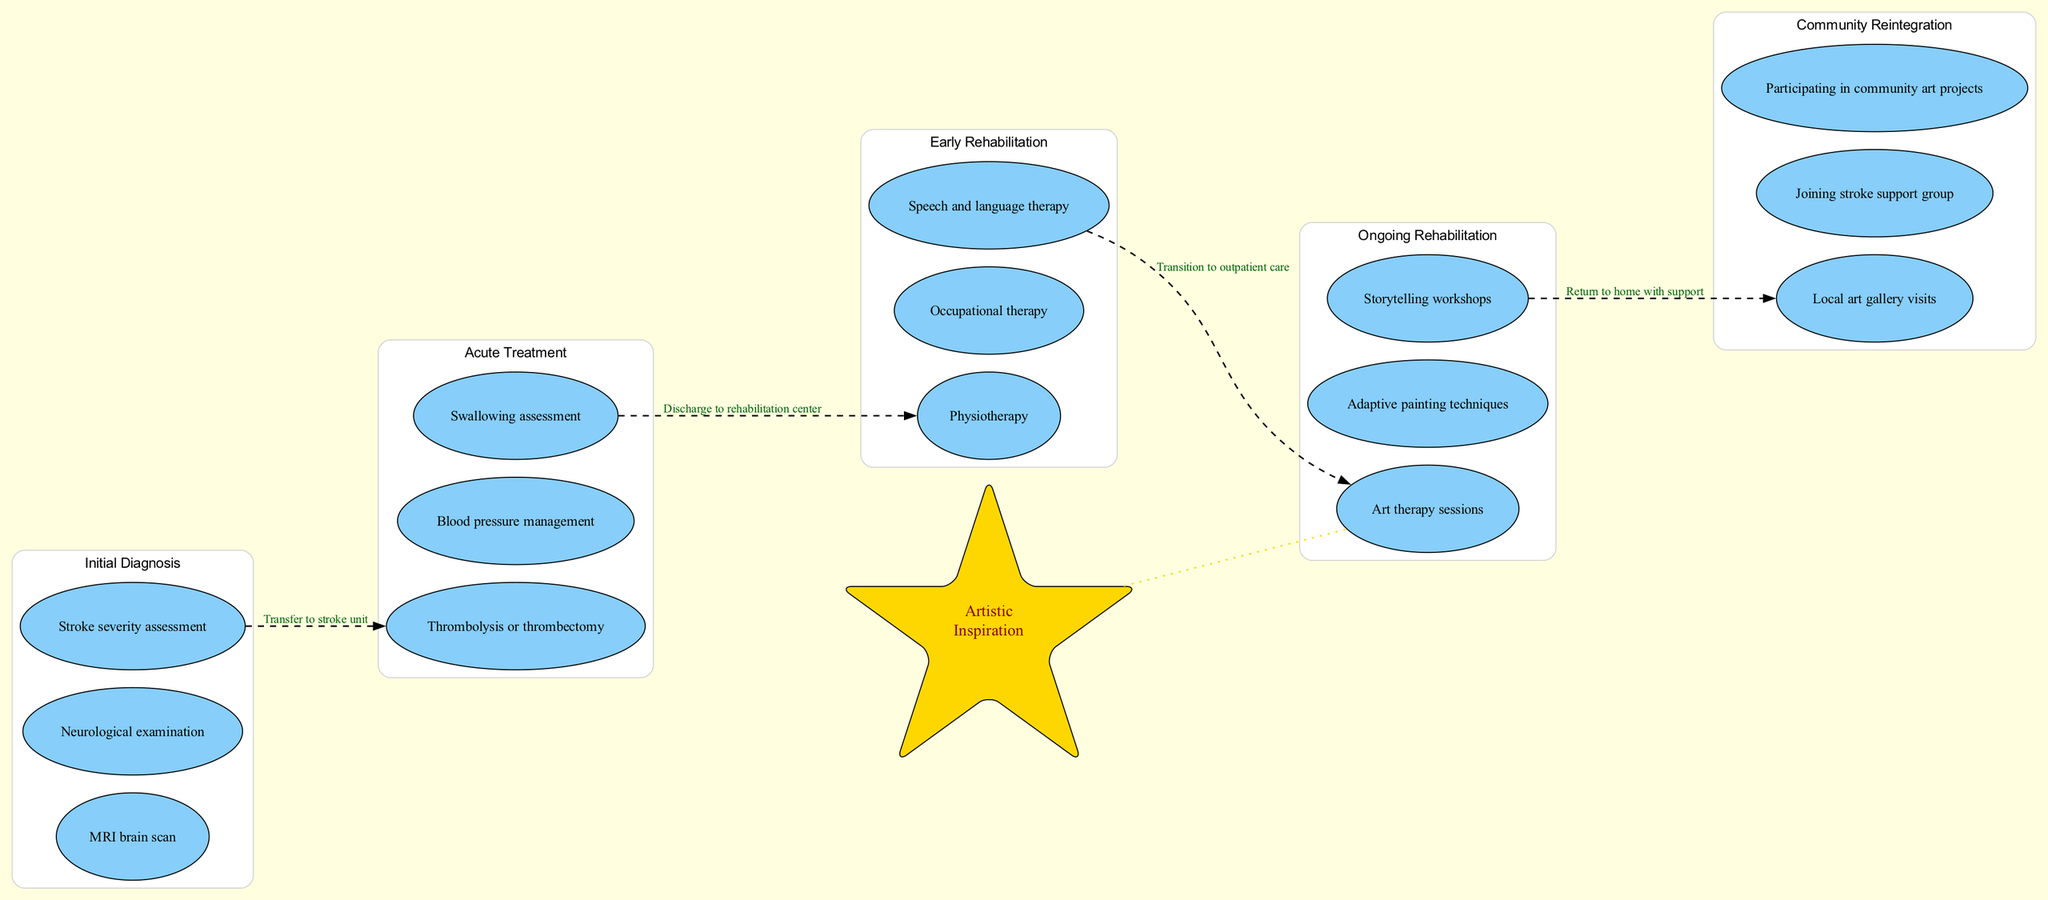What is the first stage in the pathway? The diagram lists the stages in chronological order, with the first stage clearly labeled. By looking at the first node under the 'Initial Diagnosis' cluster, I can see that the first stage is 'Initial Diagnosis'.
Answer: Initial Diagnosis How many activities are in the 'Ongoing Rehabilitation' stage? To find this, I look at the 'Ongoing Rehabilitation' section, which lists three activities: Art therapy sessions, Adaptive painting techniques, and Storytelling workshops. Thus, there are three activities in this stage.
Answer: 3 Which creative activities are included in the 'Ongoing Rehabilitation' stage? The 'Ongoing Rehabilitation' section lists three specific activities focused on creativity, which include Art therapy sessions, Adaptive painting techniques, and Storytelling workshops.
Answer: Art therapy sessions, Adaptive painting techniques, Storytelling workshops What is the transition between 'Early Rehabilitation' and 'Ongoing Rehabilitation'? The transition lines connecting the 'Early Rehabilitation' and 'Ongoing Rehabilitation' nodes indicate the flow from one stage to the next. By referring to the specific dashed edge between these two stages on the diagram, I find that the transition is labeled as 'Transition to outpatient care'.
Answer: Transition to outpatient care How many total stages are represented in the diagram? By counting the clusters in the diagram, I find five distinct stages outlined from 'Initial Diagnosis' to 'Community Reintegration'. Therefore, the total number of stages is five.
Answer: 5 